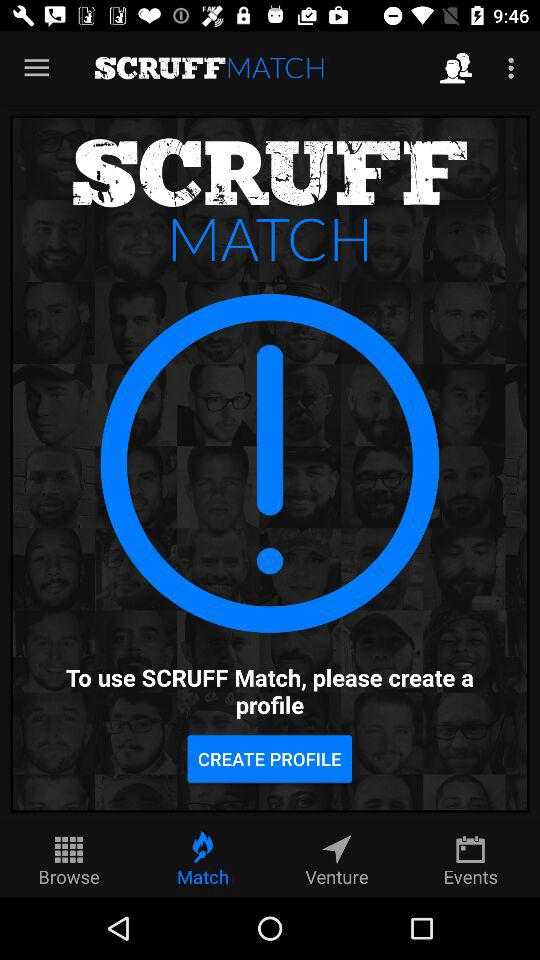What is the application name? The application name is "SCRUFF". 